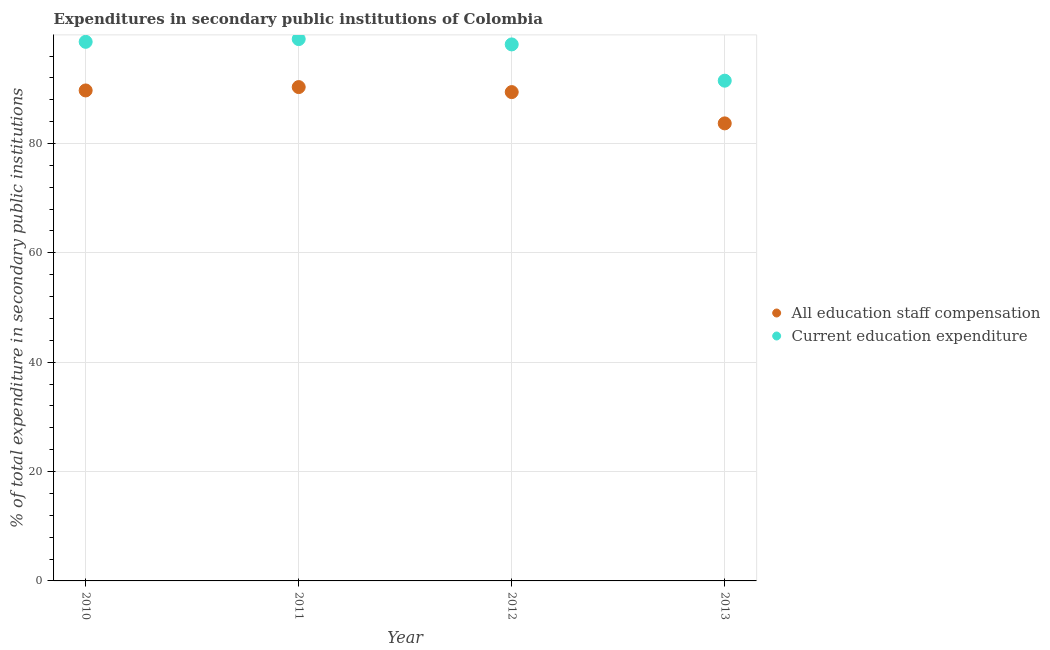Is the number of dotlines equal to the number of legend labels?
Provide a short and direct response. Yes. What is the expenditure in education in 2011?
Provide a short and direct response. 99.09. Across all years, what is the maximum expenditure in staff compensation?
Offer a very short reply. 90.32. Across all years, what is the minimum expenditure in staff compensation?
Offer a terse response. 83.68. What is the total expenditure in education in the graph?
Provide a short and direct response. 387.29. What is the difference between the expenditure in staff compensation in 2010 and that in 2013?
Ensure brevity in your answer.  6.02. What is the difference between the expenditure in staff compensation in 2011 and the expenditure in education in 2013?
Offer a terse response. -1.17. What is the average expenditure in staff compensation per year?
Provide a succinct answer. 88.27. In the year 2011, what is the difference between the expenditure in education and expenditure in staff compensation?
Offer a very short reply. 8.78. In how many years, is the expenditure in staff compensation greater than 12 %?
Ensure brevity in your answer.  4. What is the ratio of the expenditure in education in 2010 to that in 2012?
Give a very brief answer. 1. What is the difference between the highest and the second highest expenditure in education?
Provide a succinct answer. 0.5. What is the difference between the highest and the lowest expenditure in education?
Your response must be concise. 7.61. In how many years, is the expenditure in education greater than the average expenditure in education taken over all years?
Your answer should be very brief. 3. Is the expenditure in education strictly greater than the expenditure in staff compensation over the years?
Give a very brief answer. Yes. How many dotlines are there?
Your response must be concise. 2. Are the values on the major ticks of Y-axis written in scientific E-notation?
Your answer should be compact. No. Does the graph contain any zero values?
Ensure brevity in your answer.  No. How many legend labels are there?
Ensure brevity in your answer.  2. What is the title of the graph?
Ensure brevity in your answer.  Expenditures in secondary public institutions of Colombia. Does "2012 US$" appear as one of the legend labels in the graph?
Ensure brevity in your answer.  No. What is the label or title of the Y-axis?
Provide a short and direct response. % of total expenditure in secondary public institutions. What is the % of total expenditure in secondary public institutions of All education staff compensation in 2010?
Ensure brevity in your answer.  89.7. What is the % of total expenditure in secondary public institutions of Current education expenditure in 2010?
Ensure brevity in your answer.  98.59. What is the % of total expenditure in secondary public institutions in All education staff compensation in 2011?
Your response must be concise. 90.32. What is the % of total expenditure in secondary public institutions in Current education expenditure in 2011?
Ensure brevity in your answer.  99.09. What is the % of total expenditure in secondary public institutions of All education staff compensation in 2012?
Give a very brief answer. 89.4. What is the % of total expenditure in secondary public institutions of Current education expenditure in 2012?
Make the answer very short. 98.12. What is the % of total expenditure in secondary public institutions of All education staff compensation in 2013?
Provide a succinct answer. 83.68. What is the % of total expenditure in secondary public institutions in Current education expenditure in 2013?
Ensure brevity in your answer.  91.49. Across all years, what is the maximum % of total expenditure in secondary public institutions of All education staff compensation?
Offer a very short reply. 90.32. Across all years, what is the maximum % of total expenditure in secondary public institutions in Current education expenditure?
Offer a terse response. 99.09. Across all years, what is the minimum % of total expenditure in secondary public institutions of All education staff compensation?
Your answer should be compact. 83.68. Across all years, what is the minimum % of total expenditure in secondary public institutions of Current education expenditure?
Make the answer very short. 91.49. What is the total % of total expenditure in secondary public institutions in All education staff compensation in the graph?
Provide a succinct answer. 353.09. What is the total % of total expenditure in secondary public institutions in Current education expenditure in the graph?
Keep it short and to the point. 387.29. What is the difference between the % of total expenditure in secondary public institutions of All education staff compensation in 2010 and that in 2011?
Give a very brief answer. -0.62. What is the difference between the % of total expenditure in secondary public institutions of Current education expenditure in 2010 and that in 2011?
Give a very brief answer. -0.5. What is the difference between the % of total expenditure in secondary public institutions in All education staff compensation in 2010 and that in 2012?
Ensure brevity in your answer.  0.3. What is the difference between the % of total expenditure in secondary public institutions of Current education expenditure in 2010 and that in 2012?
Your answer should be compact. 0.47. What is the difference between the % of total expenditure in secondary public institutions of All education staff compensation in 2010 and that in 2013?
Provide a short and direct response. 6.02. What is the difference between the % of total expenditure in secondary public institutions in Current education expenditure in 2010 and that in 2013?
Offer a terse response. 7.11. What is the difference between the % of total expenditure in secondary public institutions of All education staff compensation in 2011 and that in 2012?
Your response must be concise. 0.92. What is the difference between the % of total expenditure in secondary public institutions in Current education expenditure in 2011 and that in 2012?
Provide a succinct answer. 0.97. What is the difference between the % of total expenditure in secondary public institutions of All education staff compensation in 2011 and that in 2013?
Your response must be concise. 6.64. What is the difference between the % of total expenditure in secondary public institutions in Current education expenditure in 2011 and that in 2013?
Offer a terse response. 7.61. What is the difference between the % of total expenditure in secondary public institutions in All education staff compensation in 2012 and that in 2013?
Offer a very short reply. 5.72. What is the difference between the % of total expenditure in secondary public institutions in Current education expenditure in 2012 and that in 2013?
Your answer should be very brief. 6.63. What is the difference between the % of total expenditure in secondary public institutions in All education staff compensation in 2010 and the % of total expenditure in secondary public institutions in Current education expenditure in 2011?
Offer a terse response. -9.39. What is the difference between the % of total expenditure in secondary public institutions in All education staff compensation in 2010 and the % of total expenditure in secondary public institutions in Current education expenditure in 2012?
Your answer should be very brief. -8.42. What is the difference between the % of total expenditure in secondary public institutions in All education staff compensation in 2010 and the % of total expenditure in secondary public institutions in Current education expenditure in 2013?
Your response must be concise. -1.79. What is the difference between the % of total expenditure in secondary public institutions in All education staff compensation in 2011 and the % of total expenditure in secondary public institutions in Current education expenditure in 2012?
Your answer should be compact. -7.8. What is the difference between the % of total expenditure in secondary public institutions in All education staff compensation in 2011 and the % of total expenditure in secondary public institutions in Current education expenditure in 2013?
Your response must be concise. -1.17. What is the difference between the % of total expenditure in secondary public institutions in All education staff compensation in 2012 and the % of total expenditure in secondary public institutions in Current education expenditure in 2013?
Your answer should be compact. -2.09. What is the average % of total expenditure in secondary public institutions of All education staff compensation per year?
Ensure brevity in your answer.  88.27. What is the average % of total expenditure in secondary public institutions of Current education expenditure per year?
Provide a succinct answer. 96.82. In the year 2010, what is the difference between the % of total expenditure in secondary public institutions in All education staff compensation and % of total expenditure in secondary public institutions in Current education expenditure?
Offer a terse response. -8.89. In the year 2011, what is the difference between the % of total expenditure in secondary public institutions of All education staff compensation and % of total expenditure in secondary public institutions of Current education expenditure?
Give a very brief answer. -8.78. In the year 2012, what is the difference between the % of total expenditure in secondary public institutions of All education staff compensation and % of total expenditure in secondary public institutions of Current education expenditure?
Make the answer very short. -8.72. In the year 2013, what is the difference between the % of total expenditure in secondary public institutions of All education staff compensation and % of total expenditure in secondary public institutions of Current education expenditure?
Ensure brevity in your answer.  -7.81. What is the ratio of the % of total expenditure in secondary public institutions of All education staff compensation in 2010 to that in 2013?
Provide a short and direct response. 1.07. What is the ratio of the % of total expenditure in secondary public institutions of Current education expenditure in 2010 to that in 2013?
Keep it short and to the point. 1.08. What is the ratio of the % of total expenditure in secondary public institutions of All education staff compensation in 2011 to that in 2012?
Provide a short and direct response. 1.01. What is the ratio of the % of total expenditure in secondary public institutions in Current education expenditure in 2011 to that in 2012?
Provide a succinct answer. 1.01. What is the ratio of the % of total expenditure in secondary public institutions of All education staff compensation in 2011 to that in 2013?
Provide a short and direct response. 1.08. What is the ratio of the % of total expenditure in secondary public institutions of Current education expenditure in 2011 to that in 2013?
Keep it short and to the point. 1.08. What is the ratio of the % of total expenditure in secondary public institutions in All education staff compensation in 2012 to that in 2013?
Your answer should be very brief. 1.07. What is the ratio of the % of total expenditure in secondary public institutions in Current education expenditure in 2012 to that in 2013?
Give a very brief answer. 1.07. What is the difference between the highest and the second highest % of total expenditure in secondary public institutions in All education staff compensation?
Keep it short and to the point. 0.62. What is the difference between the highest and the second highest % of total expenditure in secondary public institutions of Current education expenditure?
Keep it short and to the point. 0.5. What is the difference between the highest and the lowest % of total expenditure in secondary public institutions in All education staff compensation?
Give a very brief answer. 6.64. What is the difference between the highest and the lowest % of total expenditure in secondary public institutions in Current education expenditure?
Your answer should be compact. 7.61. 